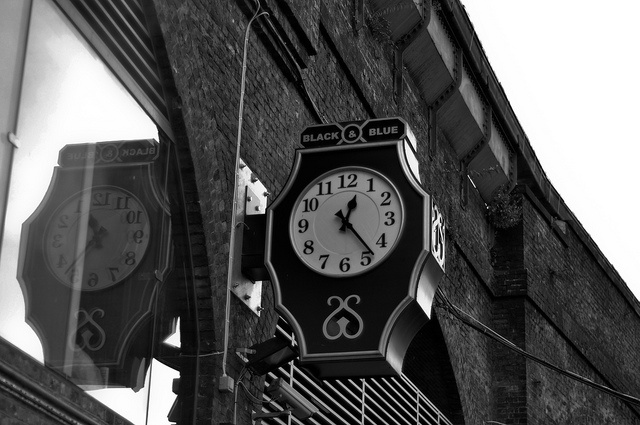Describe the objects in this image and their specific colors. I can see clock in gray, black, and lightgray tones and clock in gray, black, and white tones in this image. 